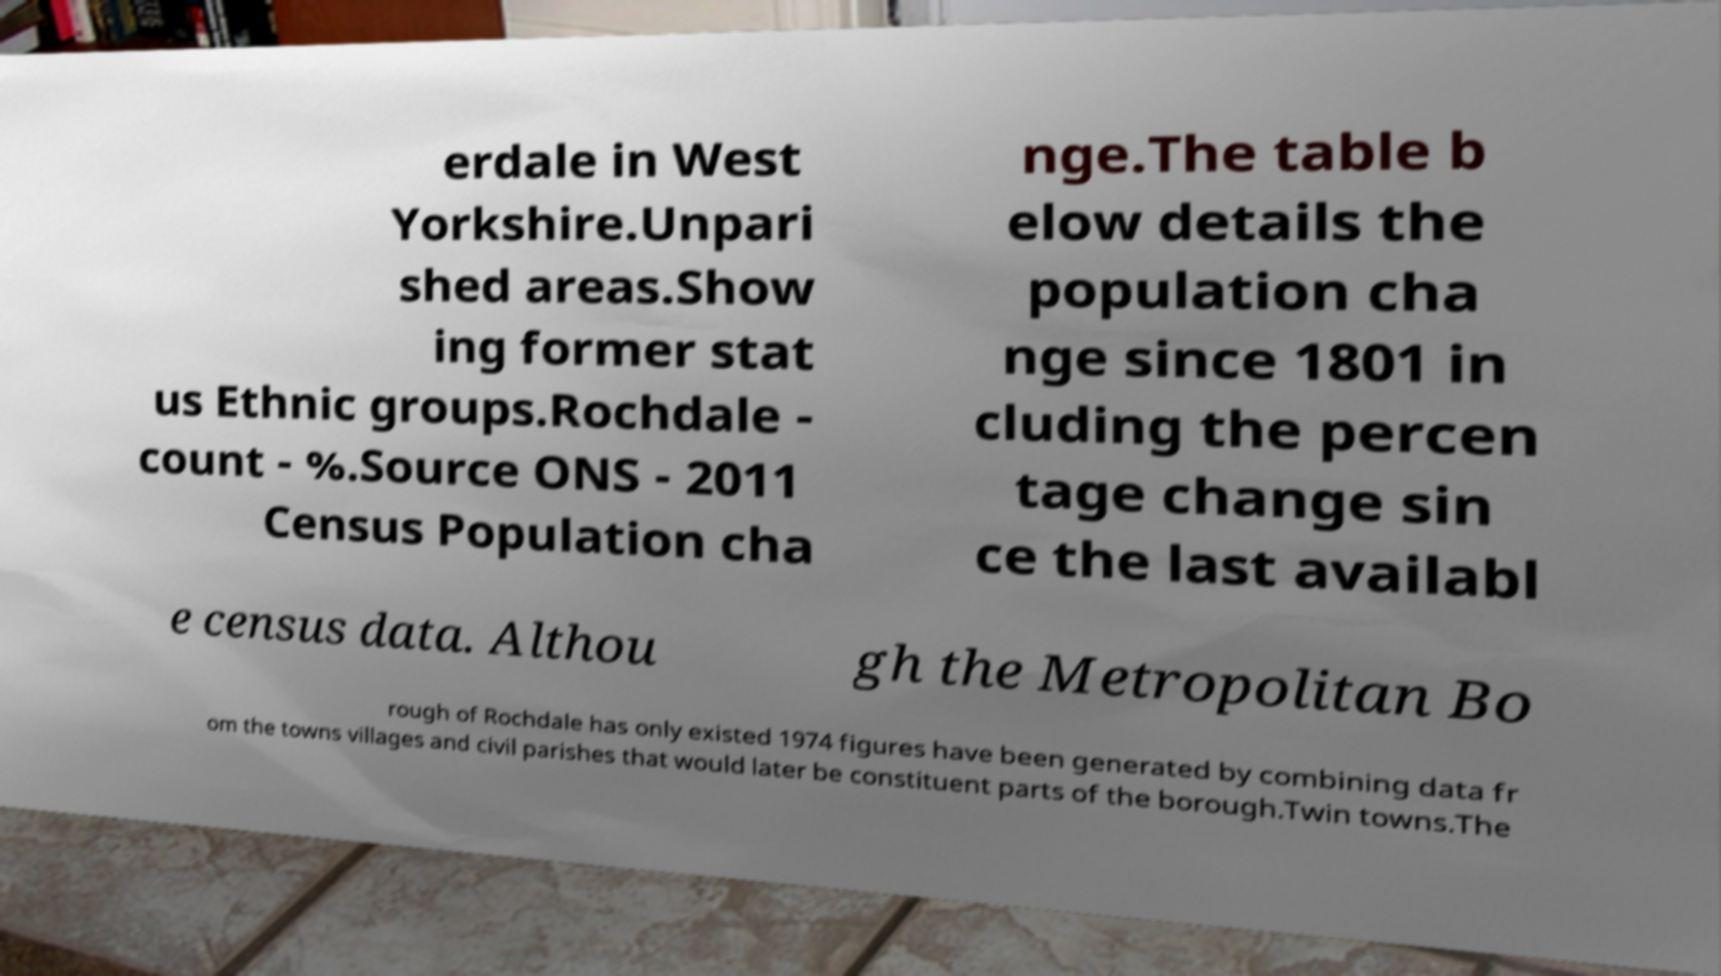Can you read and provide the text displayed in the image?This photo seems to have some interesting text. Can you extract and type it out for me? erdale in West Yorkshire.Unpari shed areas.Show ing former stat us Ethnic groups.Rochdale - count - %.Source ONS - 2011 Census Population cha nge.The table b elow details the population cha nge since 1801 in cluding the percen tage change sin ce the last availabl e census data. Althou gh the Metropolitan Bo rough of Rochdale has only existed 1974 figures have been generated by combining data fr om the towns villages and civil parishes that would later be constituent parts of the borough.Twin towns.The 